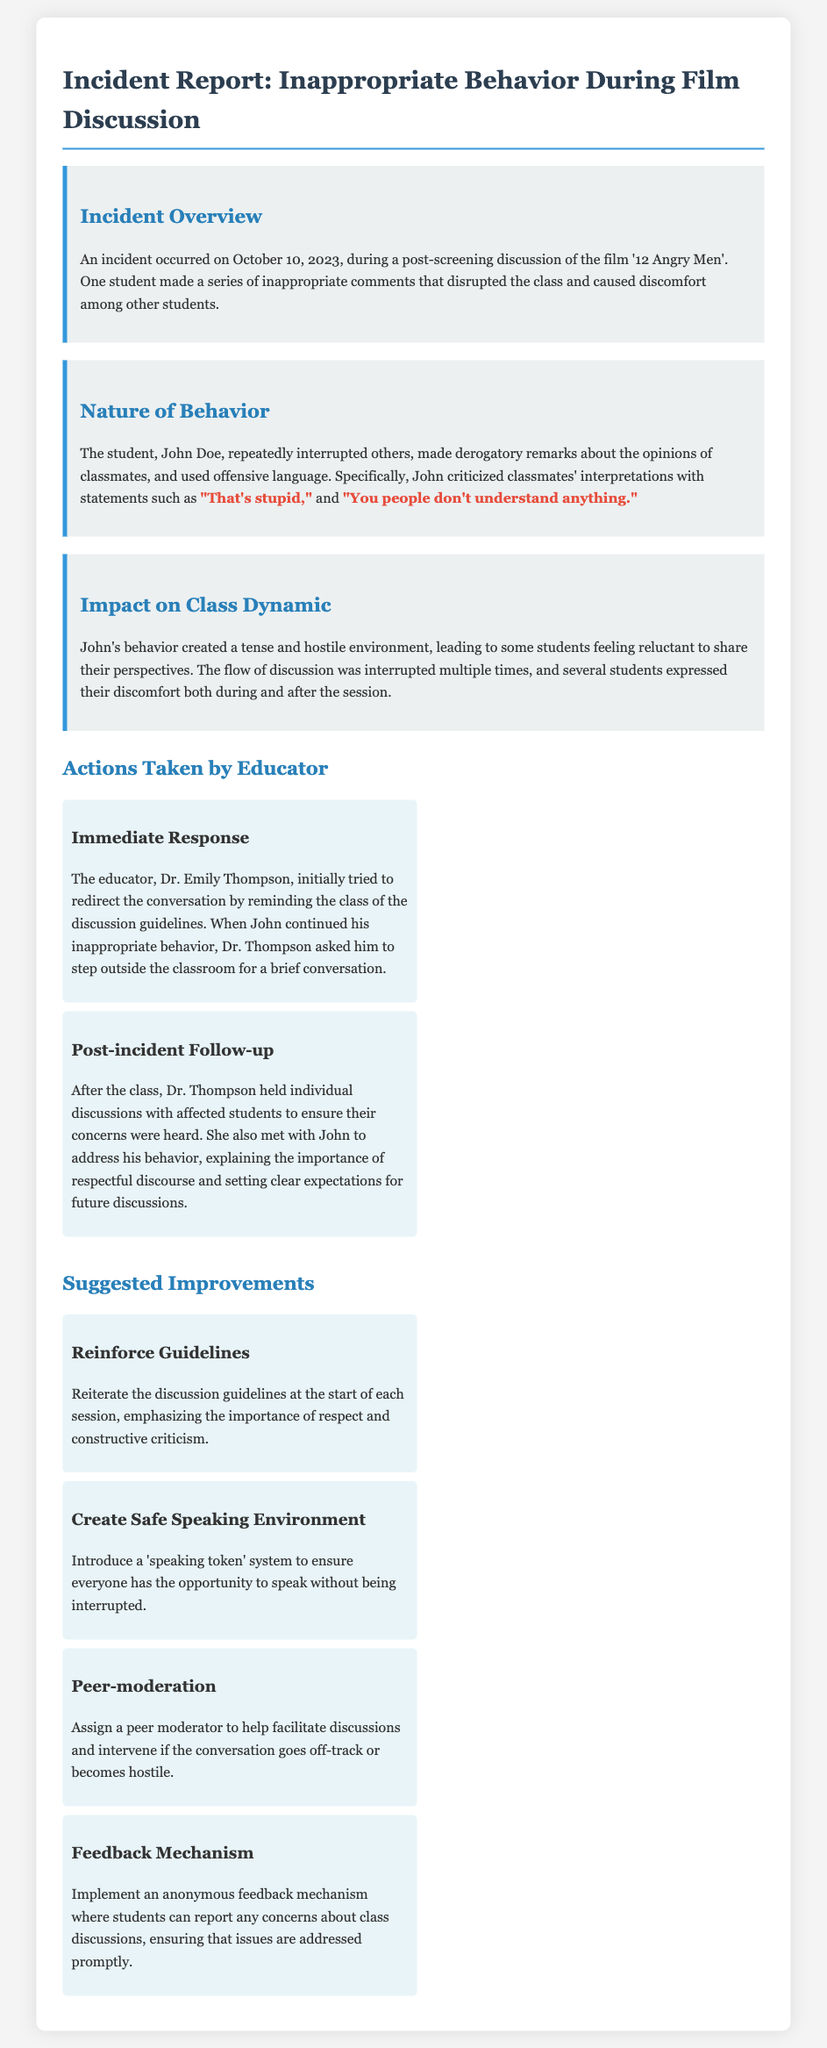what is the name of the student involved in the incident? The incident report states that the student's name is John Doe.
Answer: John Doe on what date did the incident occur? According to the document, the incident took place on October 10, 2023.
Answer: October 10, 2023 which film was discussed during the incident? The film being discussed during the incident was '12 Angry Men'.
Answer: '12 Angry Men' what were some of the derogatory remarks made by the student? The student made remarks such as "That's stupid," and "You people don't understand anything."
Answer: "That's stupid," and "You people don't understand anything." who is the educator mentioned in the report? The educator involved in the incident is Dr. Emily Thompson.
Answer: Dr. Emily Thompson what action did the educator take after the class? After the class, Dr. Thompson held individual discussions with affected students.
Answer: held individual discussions with affected students what is one suggested improvement for discussion dynamics? One suggested improvement is to introduce a 'speaking token' system.
Answer: 'speaking token' system how did John's behavior impact the class? John's behavior created a tense and hostile environment, leading to reluctance among students to share.
Answer: tense and hostile environment what mechanism is suggested for feedback on class discussions? The report suggests implementing an anonymous feedback mechanism.
Answer: anonymous feedback mechanism 